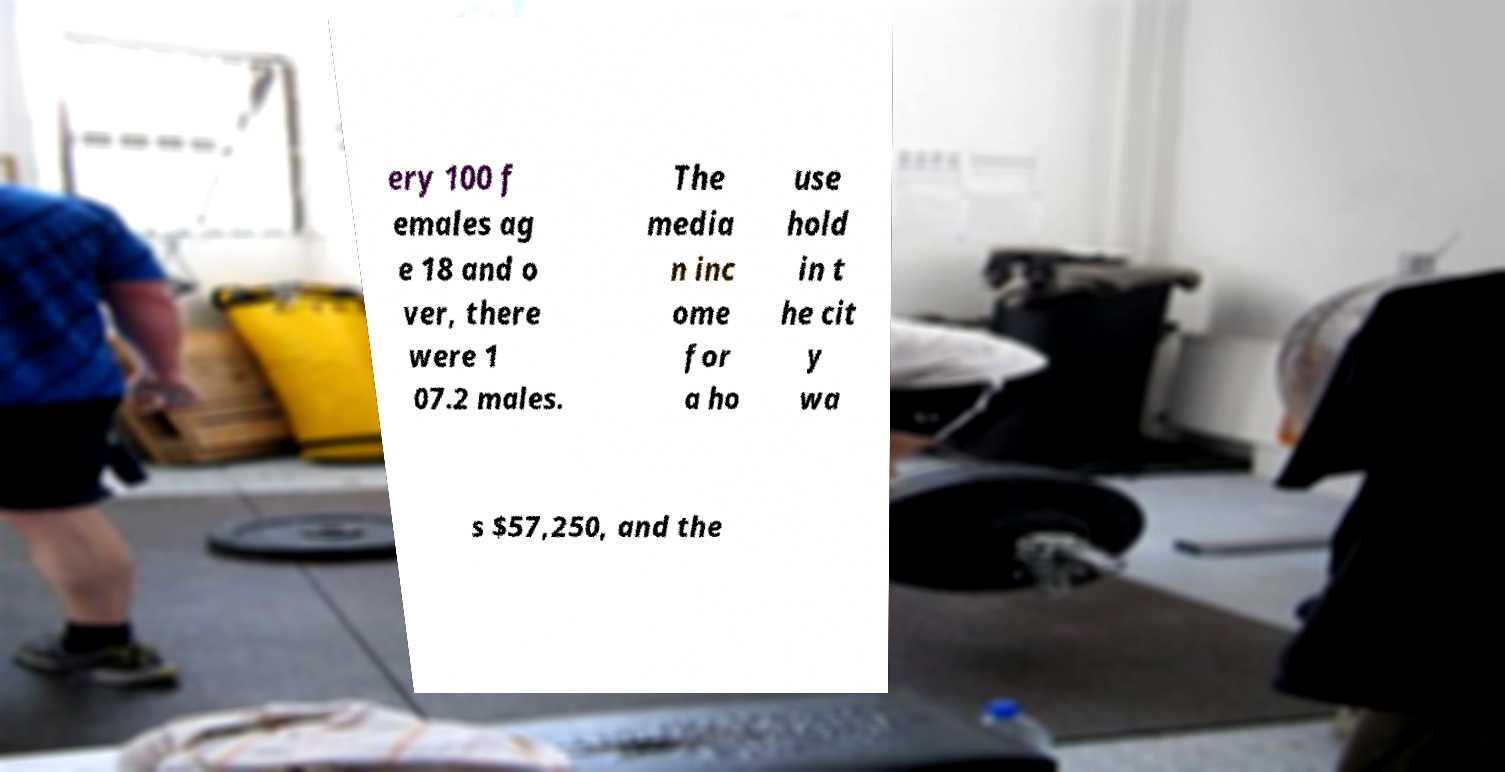What messages or text are displayed in this image? I need them in a readable, typed format. ery 100 f emales ag e 18 and o ver, there were 1 07.2 males. The media n inc ome for a ho use hold in t he cit y wa s $57,250, and the 